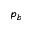<formula> <loc_0><loc_0><loc_500><loc_500>p _ { b }</formula> 